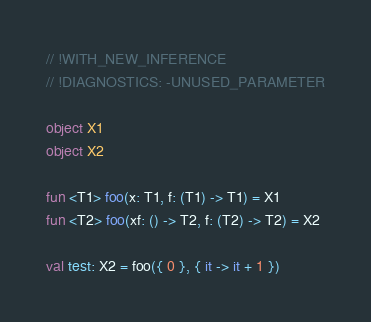<code> <loc_0><loc_0><loc_500><loc_500><_Kotlin_>// !WITH_NEW_INFERENCE
// !DIAGNOSTICS: -UNUSED_PARAMETER

object X1
object X2

fun <T1> foo(x: T1, f: (T1) -> T1) = X1
fun <T2> foo(xf: () -> T2, f: (T2) -> T2) = X2

val test: X2 = foo({ 0 }, { it -> it + 1 })
</code> 